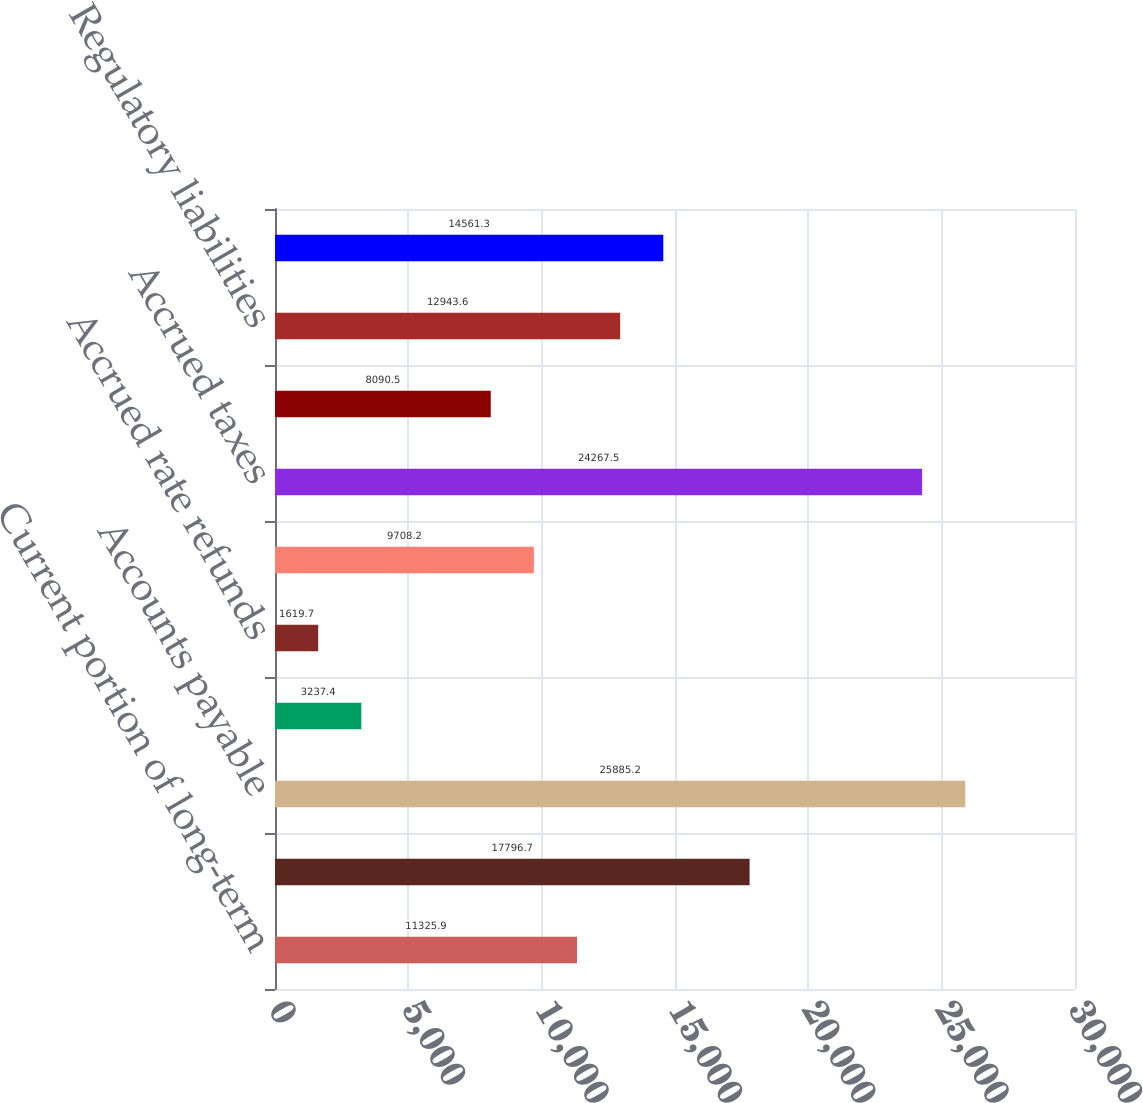<chart> <loc_0><loc_0><loc_500><loc_500><bar_chart><fcel>Current portion of long-term<fcel>Notes payable<fcel>Accounts payable<fcel>Accounts payable - related<fcel>Accrued rate refunds<fcel>Accrued interest<fcel>Accrued taxes<fcel>Deferred income taxes<fcel>Regulatory liabilities<fcel>Other current liabilities<nl><fcel>11325.9<fcel>17796.7<fcel>25885.2<fcel>3237.4<fcel>1619.7<fcel>9708.2<fcel>24267.5<fcel>8090.5<fcel>12943.6<fcel>14561.3<nl></chart> 